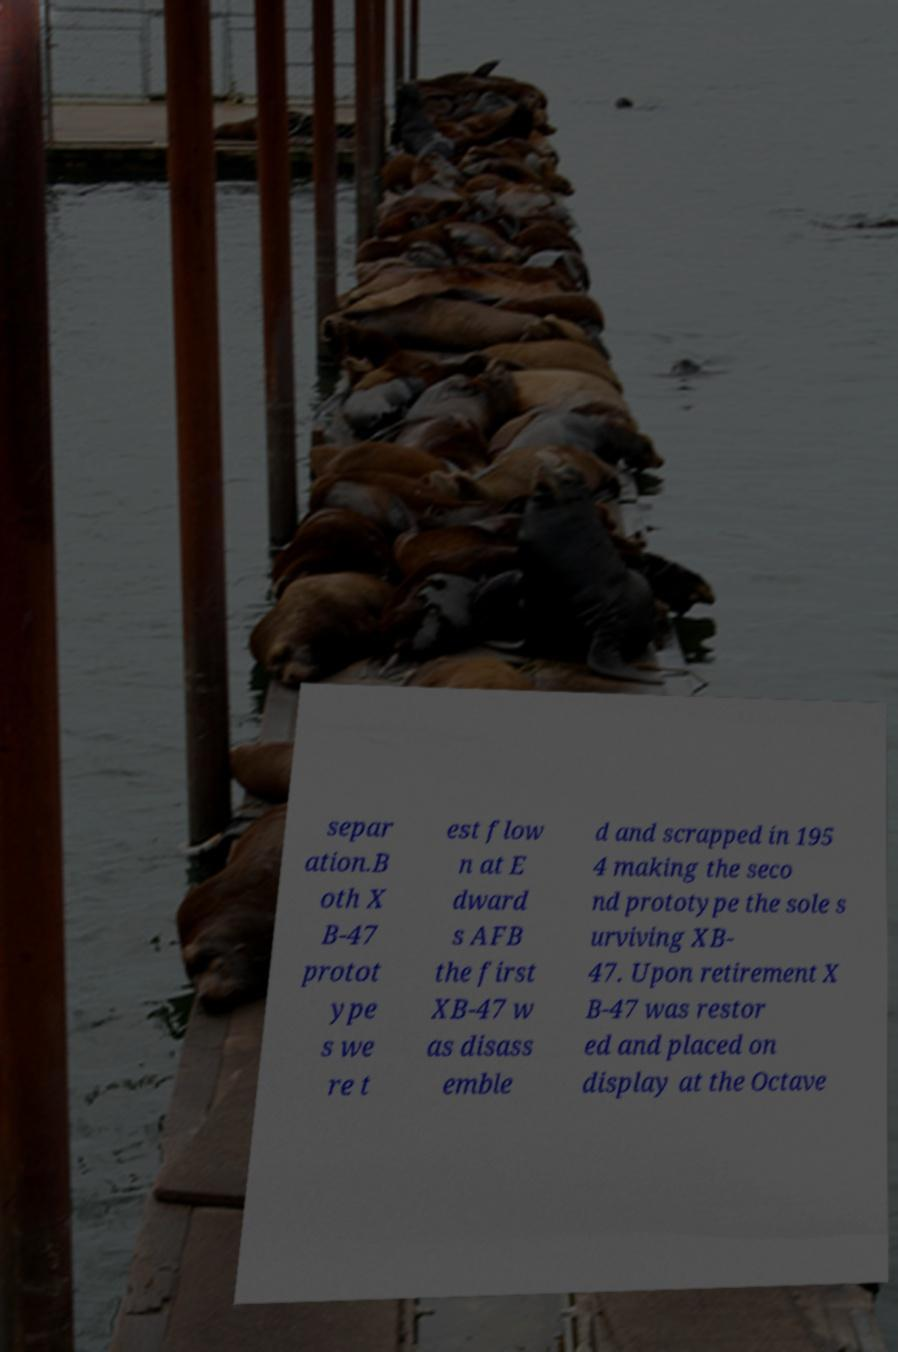For documentation purposes, I need the text within this image transcribed. Could you provide that? separ ation.B oth X B-47 protot ype s we re t est flow n at E dward s AFB the first XB-47 w as disass emble d and scrapped in 195 4 making the seco nd prototype the sole s urviving XB- 47. Upon retirement X B-47 was restor ed and placed on display at the Octave 